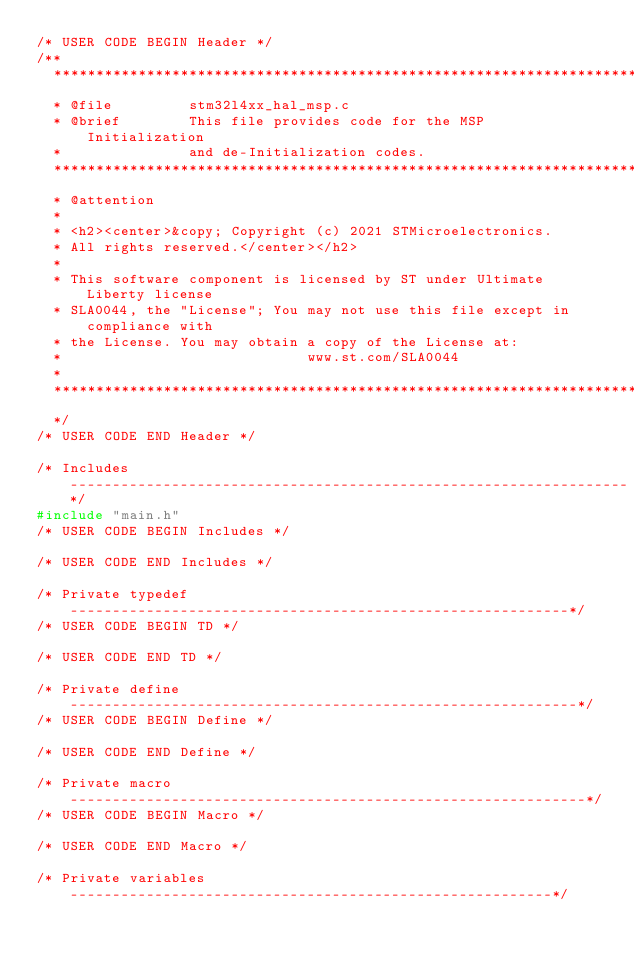<code> <loc_0><loc_0><loc_500><loc_500><_C_>/* USER CODE BEGIN Header */
/**
  ******************************************************************************
  * @file         stm32l4xx_hal_msp.c
  * @brief        This file provides code for the MSP Initialization
  *               and de-Initialization codes.
  ******************************************************************************
  * @attention
  *
  * <h2><center>&copy; Copyright (c) 2021 STMicroelectronics.
  * All rights reserved.</center></h2>
  *
  * This software component is licensed by ST under Ultimate Liberty license
  * SLA0044, the "License"; You may not use this file except in compliance with
  * the License. You may obtain a copy of the License at:
  *                             www.st.com/SLA0044
  *
  ******************************************************************************
  */
/* USER CODE END Header */

/* Includes ------------------------------------------------------------------*/
#include "main.h"
/* USER CODE BEGIN Includes */

/* USER CODE END Includes */

/* Private typedef -----------------------------------------------------------*/
/* USER CODE BEGIN TD */

/* USER CODE END TD */

/* Private define ------------------------------------------------------------*/
/* USER CODE BEGIN Define */

/* USER CODE END Define */

/* Private macro -------------------------------------------------------------*/
/* USER CODE BEGIN Macro */

/* USER CODE END Macro */

/* Private variables ---------------------------------------------------------*/</code> 